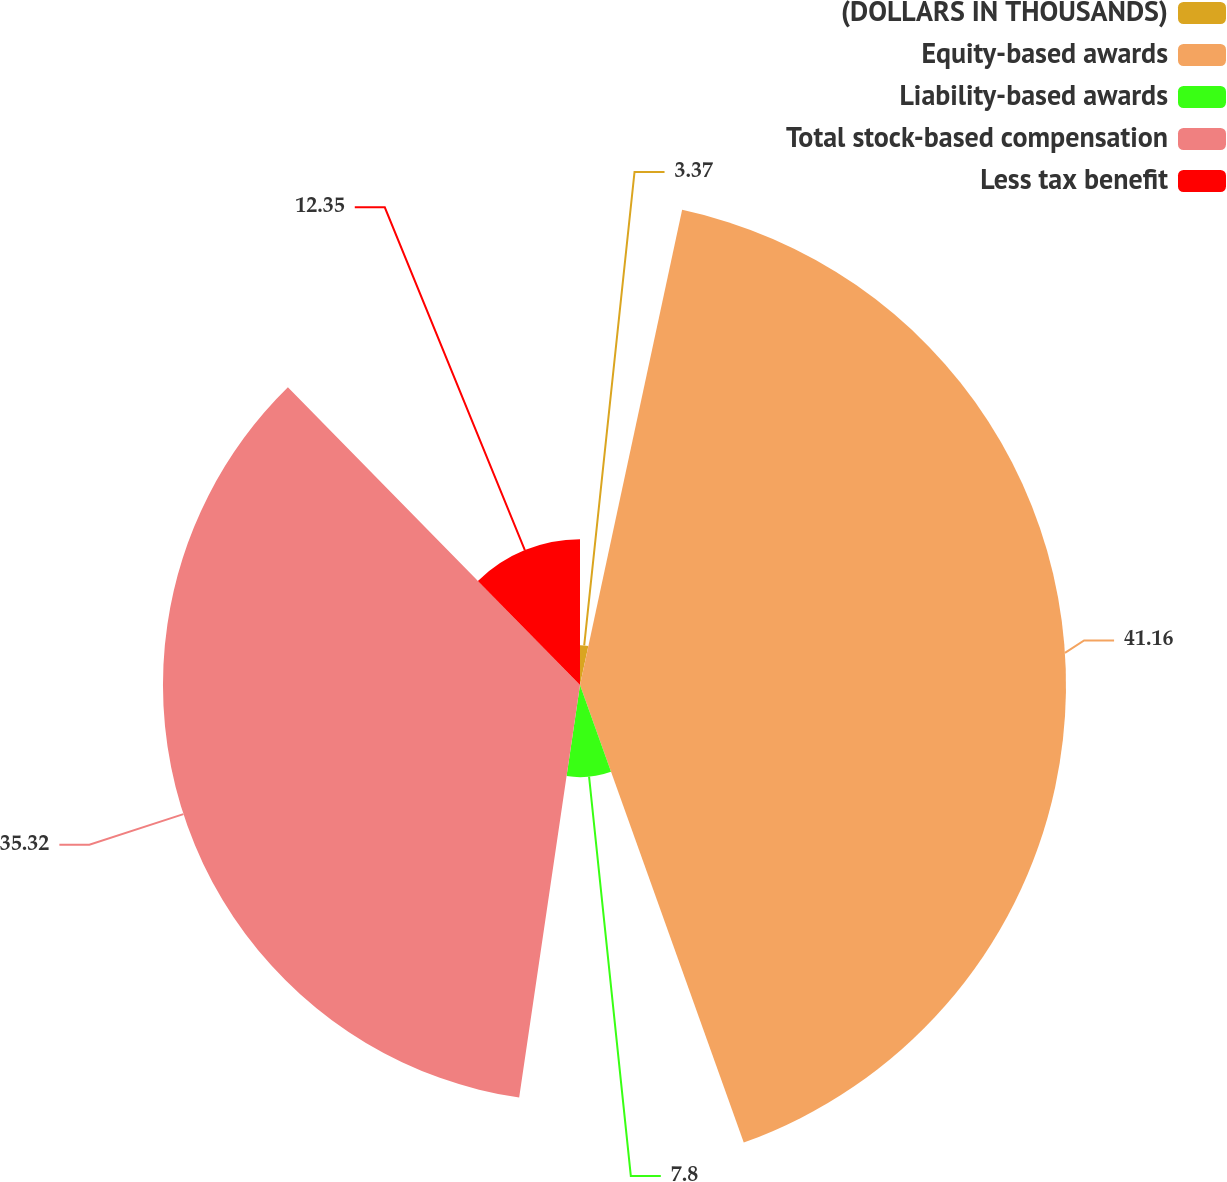<chart> <loc_0><loc_0><loc_500><loc_500><pie_chart><fcel>(DOLLARS IN THOUSANDS)<fcel>Equity-based awards<fcel>Liability-based awards<fcel>Total stock-based compensation<fcel>Less tax benefit<nl><fcel>3.37%<fcel>41.16%<fcel>7.8%<fcel>35.32%<fcel>12.35%<nl></chart> 